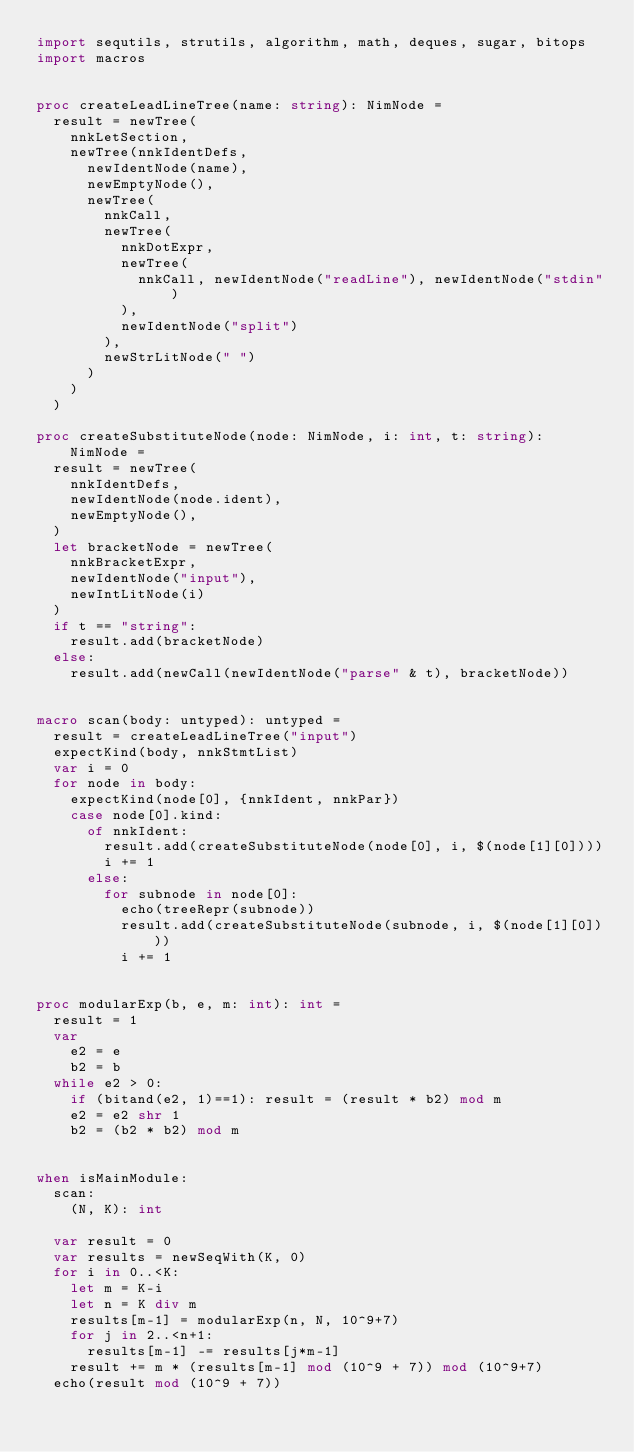<code> <loc_0><loc_0><loc_500><loc_500><_Nim_>import sequtils, strutils, algorithm, math, deques, sugar, bitops
import macros


proc createLeadLineTree(name: string): NimNode =
  result = newTree(
    nnkLetSection,
    newTree(nnkIdentDefs,
      newIdentNode(name),
      newEmptyNode(),
      newTree(
        nnkCall,
        newTree(
          nnkDotExpr,
          newTree(
            nnkCall, newIdentNode("readLine"), newIdentNode("stdin")
          ),
          newIdentNode("split")
        ),
        newStrLitNode(" ")
      )
    )
  )

proc createSubstituteNode(node: NimNode, i: int, t: string): NimNode =
  result = newTree(
    nnkIdentDefs, 
    newIdentNode(node.ident),
    newEmptyNode(),
  )
  let bracketNode = newTree(
    nnkBracketExpr,
    newIdentNode("input"),
    newIntLitNode(i)
  )
  if t == "string":
    result.add(bracketNode)
  else:
    result.add(newCall(newIdentNode("parse" & t), bracketNode))


macro scan(body: untyped): untyped =
  result = createLeadLineTree("input")
  expectKind(body, nnkStmtList)
  var i = 0
  for node in body:
    expectKind(node[0], {nnkIdent, nnkPar})
    case node[0].kind:
      of nnkIdent:
        result.add(createSubstituteNode(node[0], i, $(node[1][0])))
        i += 1
      else:
        for subnode in node[0]:
          echo(treeRepr(subnode))
          result.add(createSubstituteNode(subnode, i, $(node[1][0])))
          i += 1


proc modularExp(b, e, m: int): int =
  result = 1
  var
    e2 = e
    b2 = b
  while e2 > 0:
    if (bitand(e2, 1)==1): result = (result * b2) mod m
    e2 = e2 shr 1
    b2 = (b2 * b2) mod m


when isMainModule:
  scan:
    (N, K): int

  var result = 0
  var results = newSeqWith(K, 0)
  for i in 0..<K:
    let m = K-i
    let n = K div m
    results[m-1] = modularExp(n, N, 10^9+7)
    for j in 2..<n+1:
      results[m-1] -= results[j*m-1]
    result += m * (results[m-1] mod (10^9 + 7)) mod (10^9+7)
  echo(result mod (10^9 + 7))</code> 